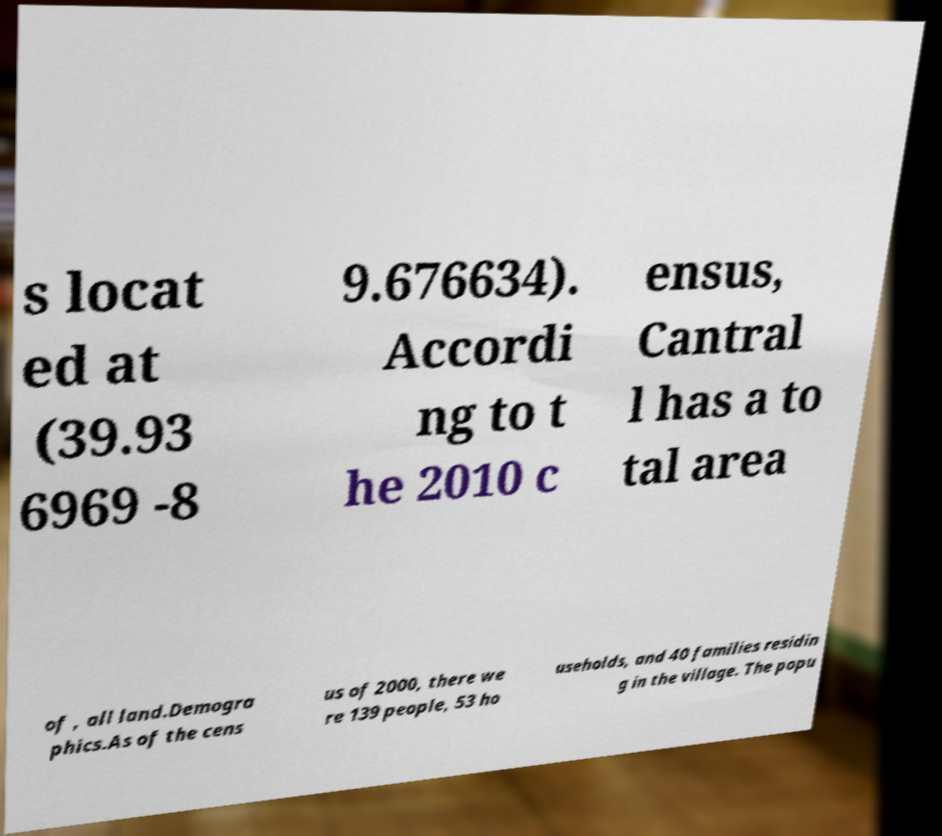For documentation purposes, I need the text within this image transcribed. Could you provide that? s locat ed at (39.93 6969 -8 9.676634). Accordi ng to t he 2010 c ensus, Cantral l has a to tal area of , all land.Demogra phics.As of the cens us of 2000, there we re 139 people, 53 ho useholds, and 40 families residin g in the village. The popu 